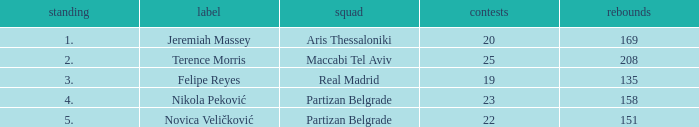How many Rebounds did Novica Veličković get in less than 22 Games? None. 